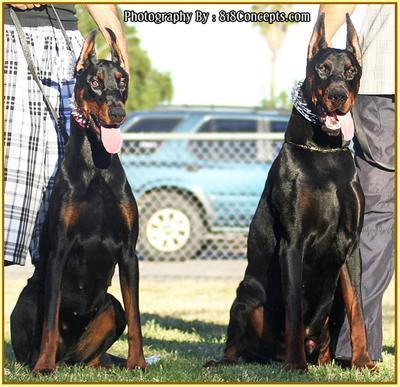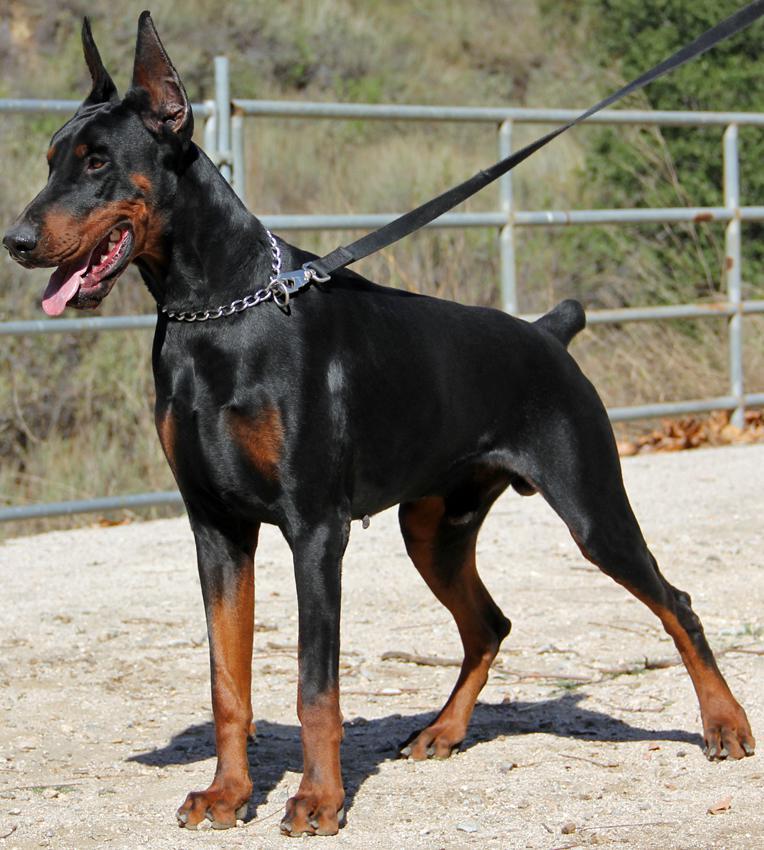The first image is the image on the left, the second image is the image on the right. Given the left and right images, does the statement "A dog has one paw off the ground." hold true? Answer yes or no. No. The first image is the image on the left, the second image is the image on the right. For the images displayed, is the sentence "One image contains a doberman sitting upright with its body turned leftward, and the other image features a doberman sitting upright with one front paw raised." factually correct? Answer yes or no. No. 